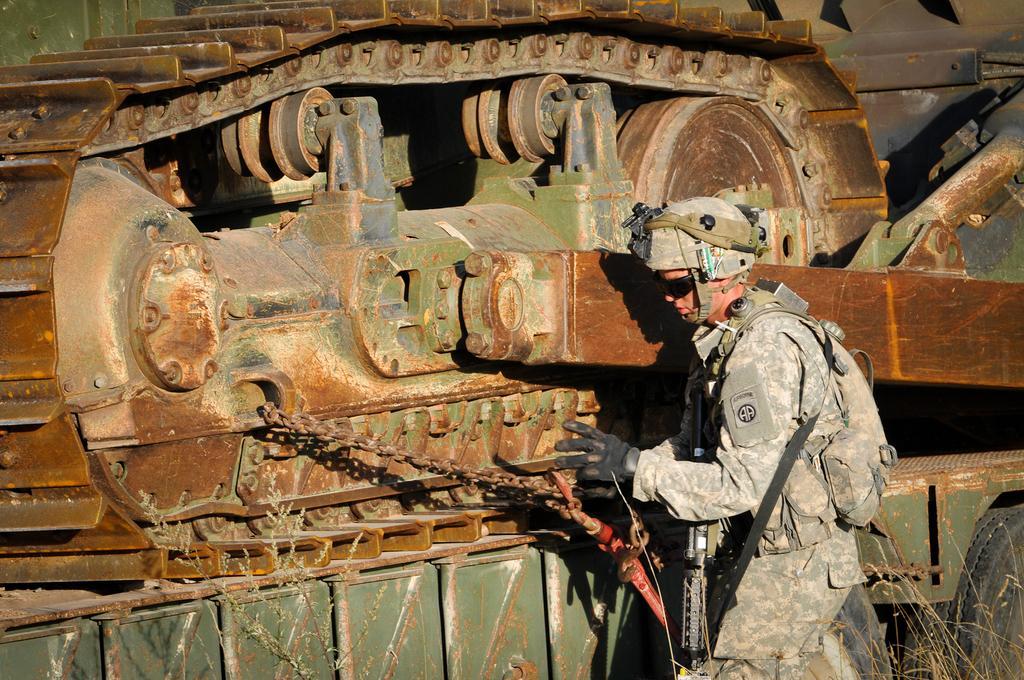Describe this image in one or two sentences. In this image there is an army standing beside a tanker. He is wearing gloves, helmet. The army is carrying bag and gun. 